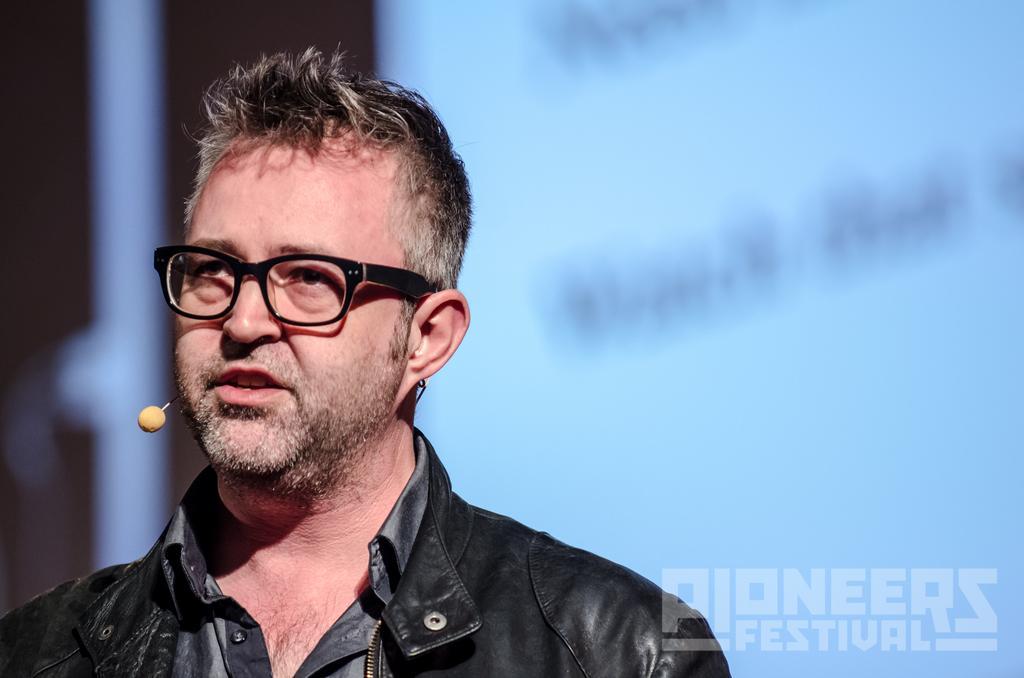Describe this image in one or two sentences. In this image we can see a man is standing, he is wearing the black glasses, here is the microphone, the background is in blue color. 